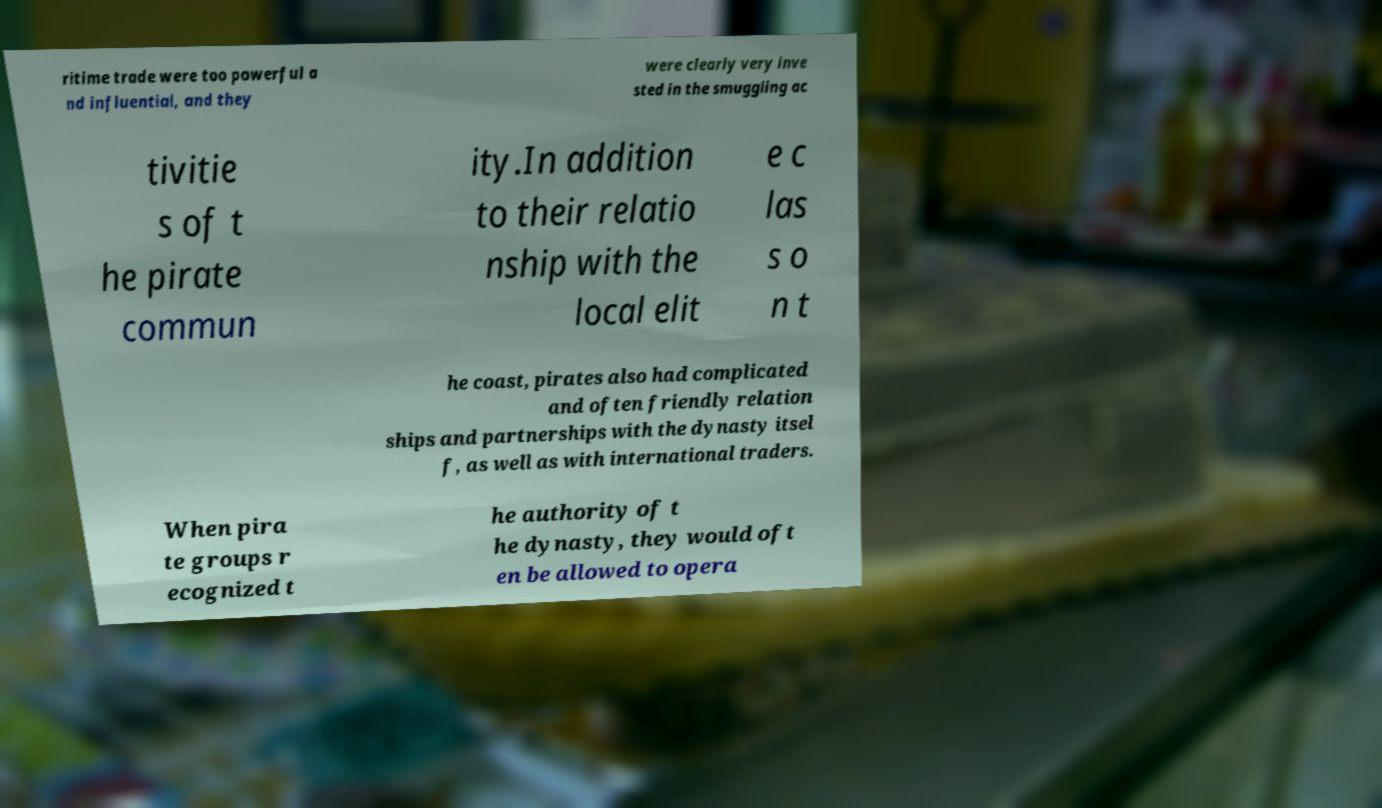I need the written content from this picture converted into text. Can you do that? ritime trade were too powerful a nd influential, and they were clearly very inve sted in the smuggling ac tivitie s of t he pirate commun ity.In addition to their relatio nship with the local elit e c las s o n t he coast, pirates also had complicated and often friendly relation ships and partnerships with the dynasty itsel f, as well as with international traders. When pira te groups r ecognized t he authority of t he dynasty, they would oft en be allowed to opera 